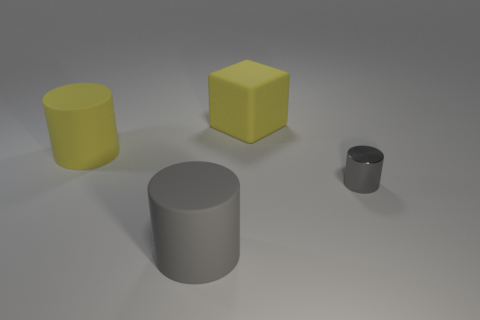Is there anything else that is the same material as the tiny gray cylinder?
Offer a terse response. No. Is the gray shiny thing the same shape as the big gray thing?
Give a very brief answer. Yes. Are there any other small gray things of the same shape as the gray rubber thing?
Keep it short and to the point. Yes. There is a large yellow rubber thing that is on the right side of the gray cylinder that is left of the yellow block; what is its shape?
Your answer should be very brief. Cube. There is a cylinder that is in front of the tiny gray object; what color is it?
Keep it short and to the point. Gray. There is another cylinder that is made of the same material as the yellow cylinder; what size is it?
Offer a terse response. Large. There is a metal thing that is the same shape as the gray matte object; what is its size?
Your answer should be compact. Small. Are there any tiny yellow matte balls?
Your response must be concise. No. What number of objects are either gray objects that are left of the yellow rubber cube or large gray objects?
Make the answer very short. 1. What is the material of the gray cylinder that is the same size as the yellow cylinder?
Provide a succinct answer. Rubber. 